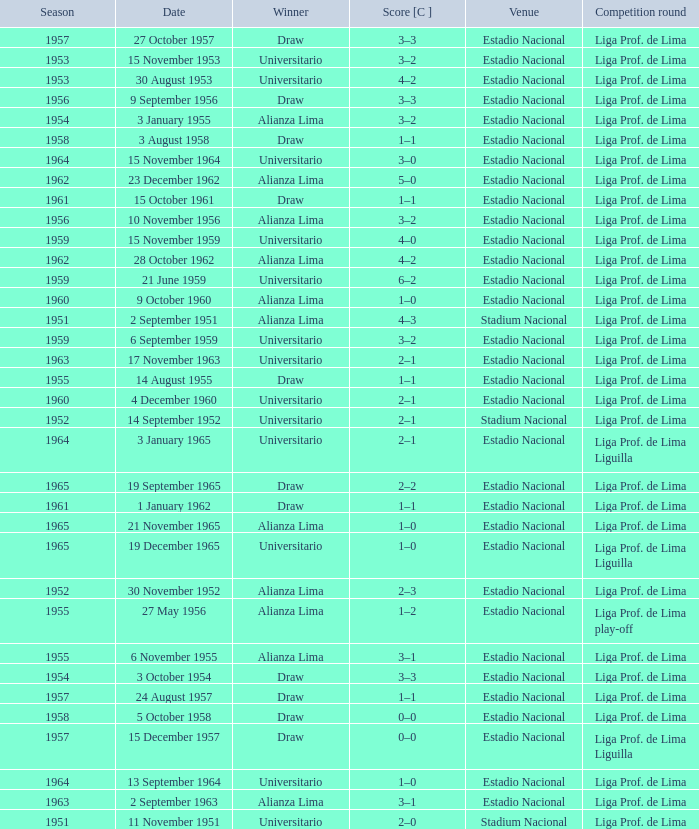What is the most recent season with a date of 27 October 1957? 1957.0. 